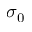<formula> <loc_0><loc_0><loc_500><loc_500>\sigma _ { 0 }</formula> 